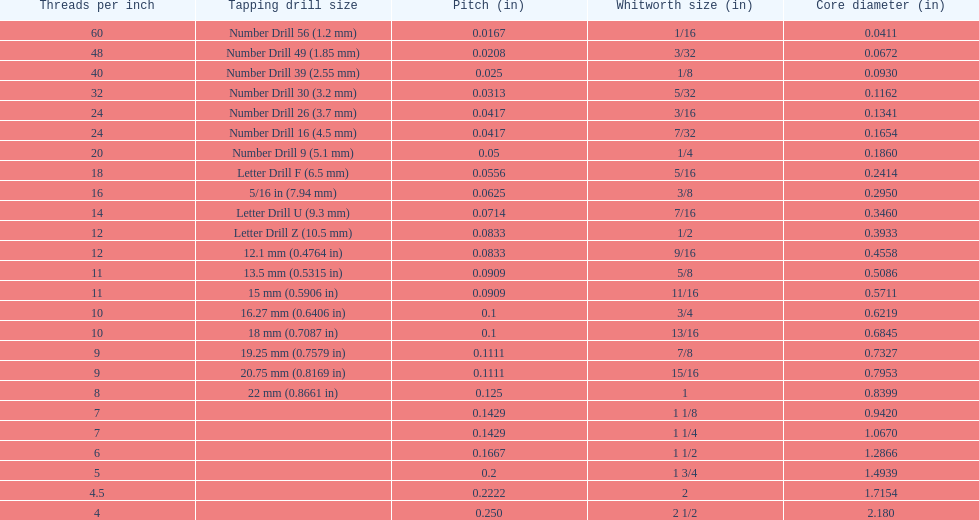What is the minimum diameter of the core, measured in inches? 0.0411. 